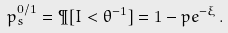<formula> <loc_0><loc_0><loc_500><loc_500>p _ { s } ^ { 0 / 1 } = \P [ I < \theta ^ { - 1 } ] = 1 - p e ^ { - \xi } \, .</formula> 